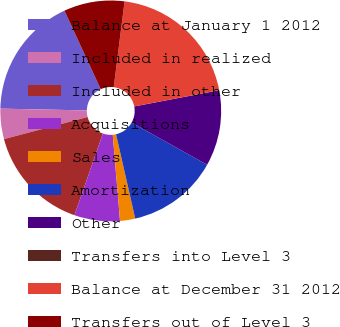<chart> <loc_0><loc_0><loc_500><loc_500><pie_chart><fcel>Balance at January 1 2012<fcel>Included in realized<fcel>Included in other<fcel>Acquisitions<fcel>Sales<fcel>Amortization<fcel>Other<fcel>Transfers into Level 3<fcel>Balance at December 31 2012<fcel>Transfers out of Level 3<nl><fcel>17.78%<fcel>4.44%<fcel>15.56%<fcel>6.67%<fcel>2.22%<fcel>13.33%<fcel>11.11%<fcel>0.0%<fcel>20.0%<fcel>8.89%<nl></chart> 